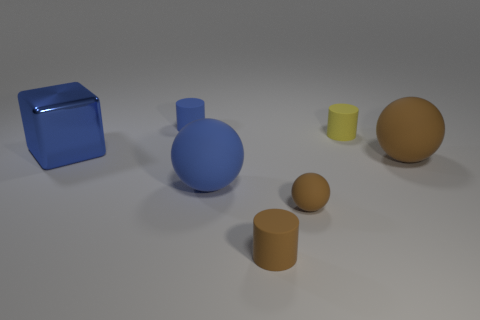Add 3 rubber things. How many objects exist? 10 Subtract all blocks. How many objects are left? 6 Add 1 big brown things. How many big brown things are left? 2 Add 2 balls. How many balls exist? 5 Subtract 0 purple balls. How many objects are left? 7 Subtract all tiny cyan cubes. Subtract all rubber balls. How many objects are left? 4 